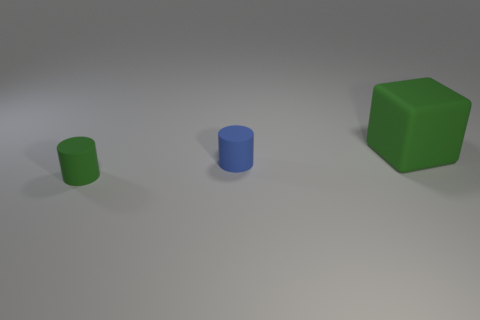Add 2 green cylinders. How many objects exist? 5 Subtract all blue blocks. Subtract all red cylinders. How many blocks are left? 1 Subtract all cubes. How many objects are left? 2 Add 2 big purple metallic cylinders. How many big purple metallic cylinders exist? 2 Subtract 0 brown spheres. How many objects are left? 3 Subtract all cubes. Subtract all blue things. How many objects are left? 1 Add 2 blue cylinders. How many blue cylinders are left? 3 